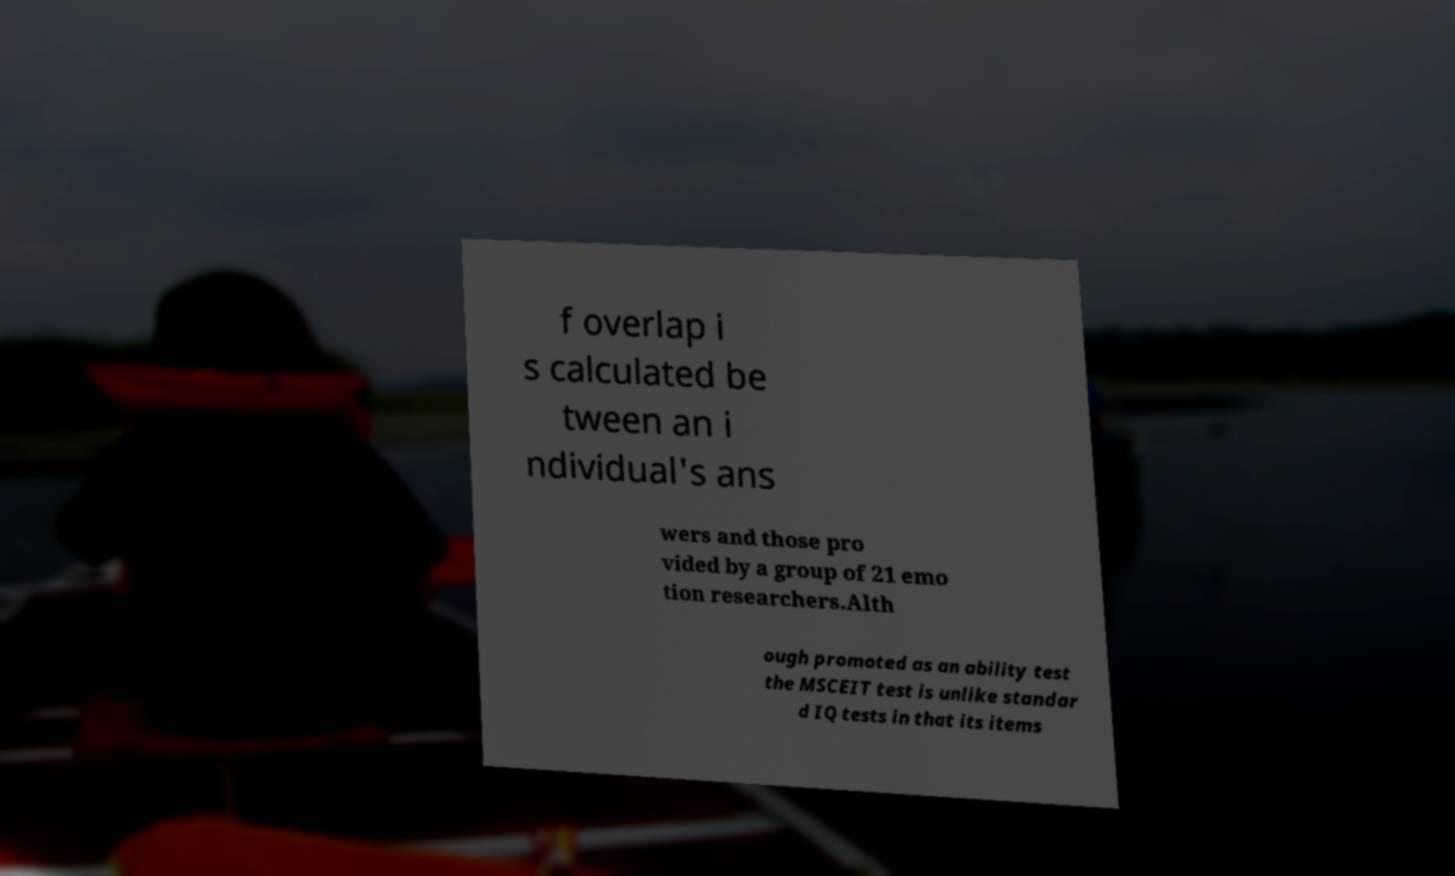For documentation purposes, I need the text within this image transcribed. Could you provide that? f overlap i s calculated be tween an i ndividual's ans wers and those pro vided by a group of 21 emo tion researchers.Alth ough promoted as an ability test the MSCEIT test is unlike standar d IQ tests in that its items 